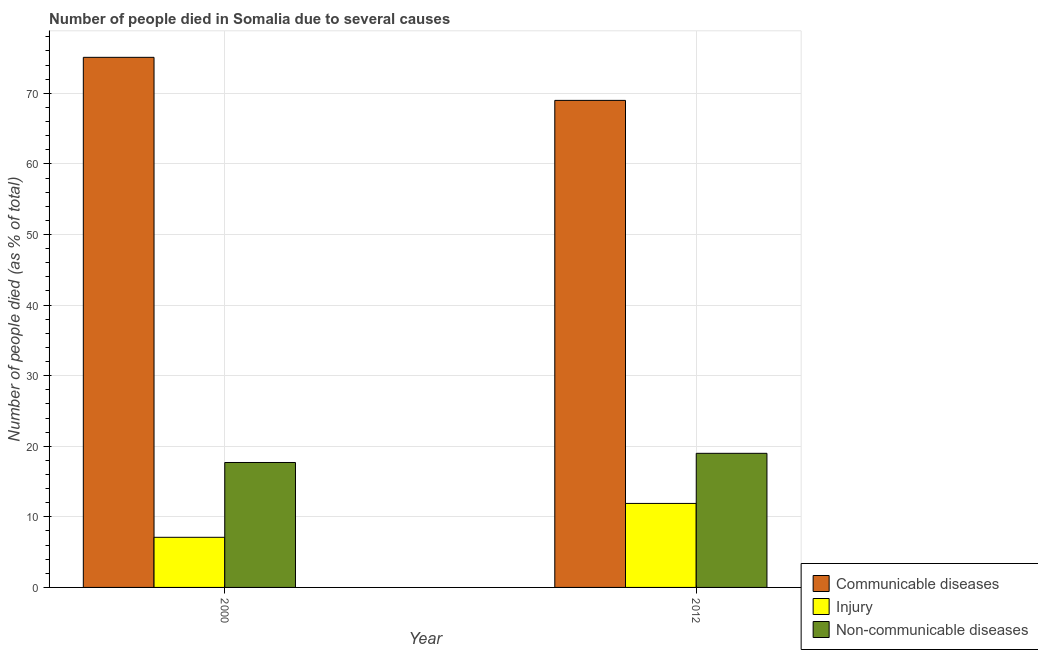How many different coloured bars are there?
Your answer should be compact. 3. How many groups of bars are there?
Your response must be concise. 2. How many bars are there on the 2nd tick from the right?
Offer a terse response. 3. What is the label of the 2nd group of bars from the left?
Keep it short and to the point. 2012. Across all years, what is the maximum number of people who died of communicable diseases?
Your answer should be very brief. 75.1. Across all years, what is the minimum number of people who died of communicable diseases?
Make the answer very short. 69. What is the total number of people who died of communicable diseases in the graph?
Offer a terse response. 144.1. What is the difference between the number of people who died of injury in 2000 and that in 2012?
Offer a very short reply. -4.8. What is the difference between the number of people who died of injury in 2000 and the number of people who dies of non-communicable diseases in 2012?
Offer a terse response. -4.8. What is the average number of people who dies of non-communicable diseases per year?
Keep it short and to the point. 18.35. In the year 2012, what is the difference between the number of people who dies of non-communicable diseases and number of people who died of injury?
Provide a succinct answer. 0. In how many years, is the number of people who dies of non-communicable diseases greater than 14 %?
Give a very brief answer. 2. What is the ratio of the number of people who dies of non-communicable diseases in 2000 to that in 2012?
Ensure brevity in your answer.  0.93. What does the 1st bar from the left in 2012 represents?
Give a very brief answer. Communicable diseases. What does the 3rd bar from the right in 2000 represents?
Your response must be concise. Communicable diseases. Is it the case that in every year, the sum of the number of people who died of communicable diseases and number of people who died of injury is greater than the number of people who dies of non-communicable diseases?
Provide a short and direct response. Yes. How many bars are there?
Provide a succinct answer. 6. Are all the bars in the graph horizontal?
Offer a terse response. No. How many years are there in the graph?
Your answer should be compact. 2. What is the difference between two consecutive major ticks on the Y-axis?
Make the answer very short. 10. Are the values on the major ticks of Y-axis written in scientific E-notation?
Ensure brevity in your answer.  No. Does the graph contain grids?
Make the answer very short. Yes. How are the legend labels stacked?
Your answer should be compact. Vertical. What is the title of the graph?
Keep it short and to the point. Number of people died in Somalia due to several causes. Does "Ages 60+" appear as one of the legend labels in the graph?
Make the answer very short. No. What is the label or title of the Y-axis?
Offer a very short reply. Number of people died (as % of total). What is the Number of people died (as % of total) of Communicable diseases in 2000?
Offer a terse response. 75.1. What is the Number of people died (as % of total) of Injury in 2000?
Your response must be concise. 7.1. What is the Number of people died (as % of total) in Non-communicable diseases in 2000?
Offer a very short reply. 17.7. What is the Number of people died (as % of total) of Communicable diseases in 2012?
Your response must be concise. 69. Across all years, what is the maximum Number of people died (as % of total) in Communicable diseases?
Offer a terse response. 75.1. Across all years, what is the maximum Number of people died (as % of total) in Injury?
Your answer should be compact. 11.9. Across all years, what is the minimum Number of people died (as % of total) of Non-communicable diseases?
Your answer should be compact. 17.7. What is the total Number of people died (as % of total) in Communicable diseases in the graph?
Give a very brief answer. 144.1. What is the total Number of people died (as % of total) in Injury in the graph?
Offer a very short reply. 19. What is the total Number of people died (as % of total) in Non-communicable diseases in the graph?
Your answer should be compact. 36.7. What is the difference between the Number of people died (as % of total) in Communicable diseases in 2000 and that in 2012?
Provide a succinct answer. 6.1. What is the difference between the Number of people died (as % of total) of Injury in 2000 and that in 2012?
Offer a terse response. -4.8. What is the difference between the Number of people died (as % of total) in Communicable diseases in 2000 and the Number of people died (as % of total) in Injury in 2012?
Provide a short and direct response. 63.2. What is the difference between the Number of people died (as % of total) of Communicable diseases in 2000 and the Number of people died (as % of total) of Non-communicable diseases in 2012?
Your answer should be very brief. 56.1. What is the difference between the Number of people died (as % of total) of Injury in 2000 and the Number of people died (as % of total) of Non-communicable diseases in 2012?
Offer a very short reply. -11.9. What is the average Number of people died (as % of total) in Communicable diseases per year?
Ensure brevity in your answer.  72.05. What is the average Number of people died (as % of total) of Non-communicable diseases per year?
Your response must be concise. 18.35. In the year 2000, what is the difference between the Number of people died (as % of total) of Communicable diseases and Number of people died (as % of total) of Injury?
Provide a short and direct response. 68. In the year 2000, what is the difference between the Number of people died (as % of total) in Communicable diseases and Number of people died (as % of total) in Non-communicable diseases?
Offer a very short reply. 57.4. In the year 2000, what is the difference between the Number of people died (as % of total) of Injury and Number of people died (as % of total) of Non-communicable diseases?
Make the answer very short. -10.6. In the year 2012, what is the difference between the Number of people died (as % of total) of Communicable diseases and Number of people died (as % of total) of Injury?
Give a very brief answer. 57.1. In the year 2012, what is the difference between the Number of people died (as % of total) of Injury and Number of people died (as % of total) of Non-communicable diseases?
Provide a short and direct response. -7.1. What is the ratio of the Number of people died (as % of total) of Communicable diseases in 2000 to that in 2012?
Your answer should be compact. 1.09. What is the ratio of the Number of people died (as % of total) in Injury in 2000 to that in 2012?
Provide a succinct answer. 0.6. What is the ratio of the Number of people died (as % of total) of Non-communicable diseases in 2000 to that in 2012?
Give a very brief answer. 0.93. What is the difference between the highest and the second highest Number of people died (as % of total) of Communicable diseases?
Offer a very short reply. 6.1. What is the difference between the highest and the second highest Number of people died (as % of total) in Non-communicable diseases?
Keep it short and to the point. 1.3. What is the difference between the highest and the lowest Number of people died (as % of total) of Non-communicable diseases?
Give a very brief answer. 1.3. 